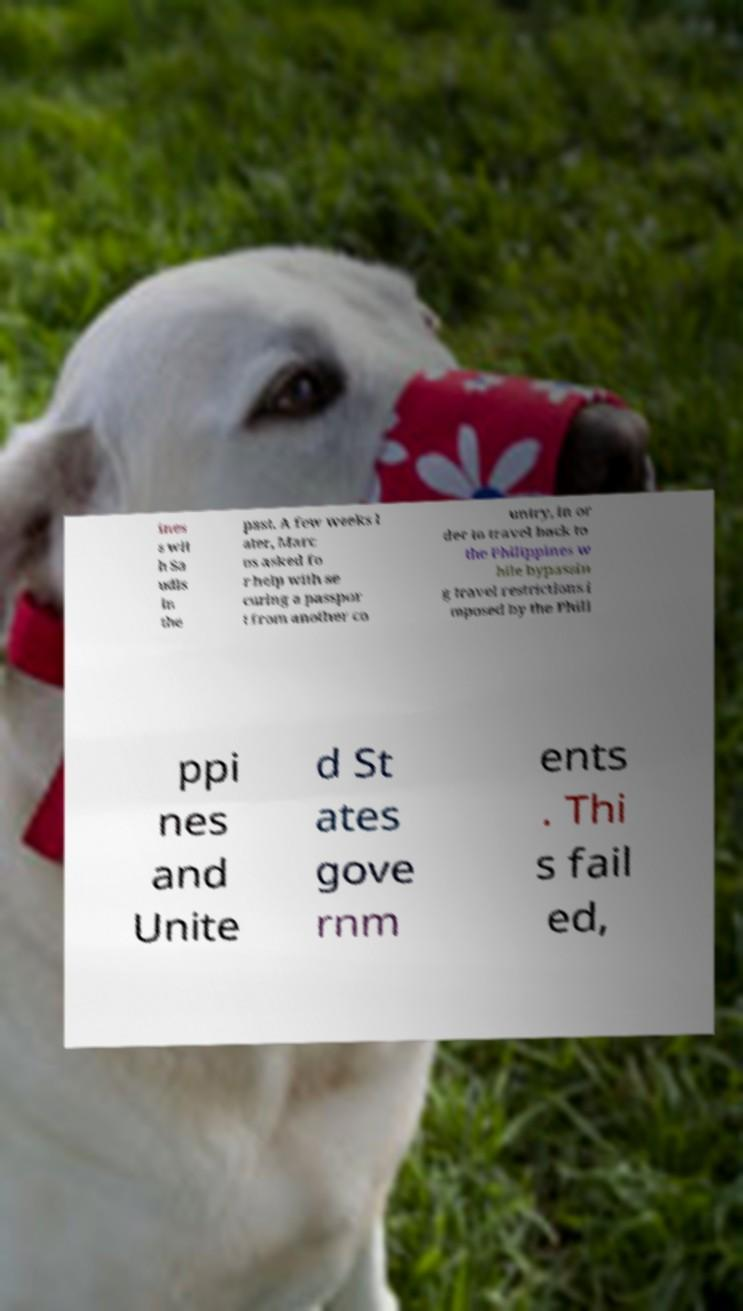Can you accurately transcribe the text from the provided image for me? ines s wit h Sa udis in the past. A few weeks l ater, Marc os asked fo r help with se curing a passpor t from another co untry, in or der to travel back to the Philippines w hile bypassin g travel restrictions i mposed by the Phili ppi nes and Unite d St ates gove rnm ents . Thi s fail ed, 